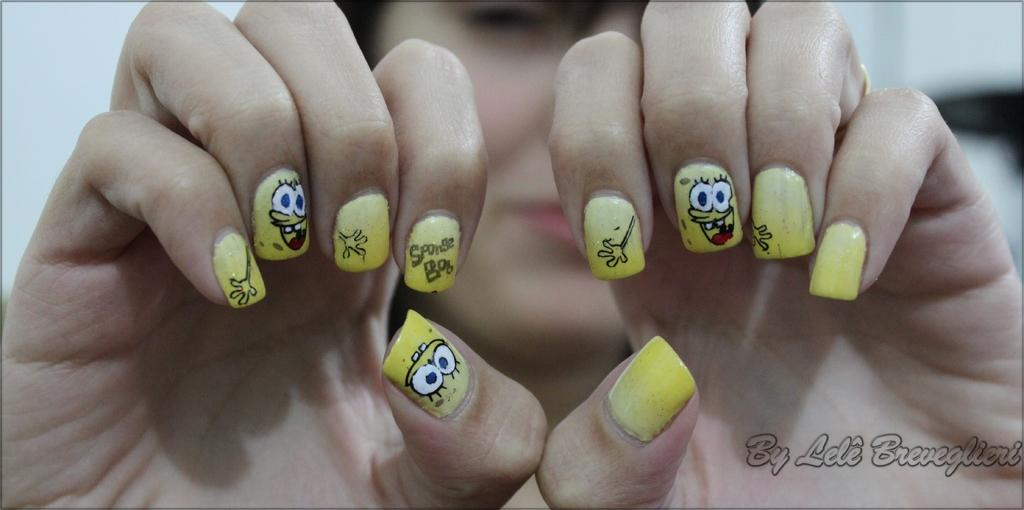Who is present in the image? There is a woman in the image. What objects can be seen in the image? There are nails in the image. What type of magic is the woman performing with the scarecrow in the image? There is no scarecrow present in the image, and no magic is being performed. 